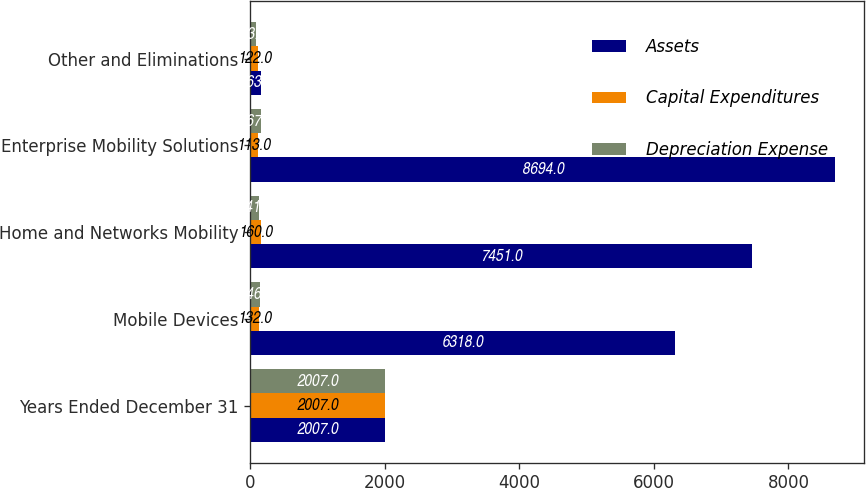Convert chart to OTSL. <chart><loc_0><loc_0><loc_500><loc_500><stacked_bar_chart><ecel><fcel>Years Ended December 31<fcel>Mobile Devices<fcel>Home and Networks Mobility<fcel>Enterprise Mobility Solutions<fcel>Other and Eliminations<nl><fcel>Assets<fcel>2007<fcel>6318<fcel>7451<fcel>8694<fcel>163.5<nl><fcel>Capital Expenditures<fcel>2007<fcel>132<fcel>160<fcel>113<fcel>122<nl><fcel>Depreciation Expense<fcel>2007<fcel>146<fcel>141<fcel>167<fcel>83<nl></chart> 